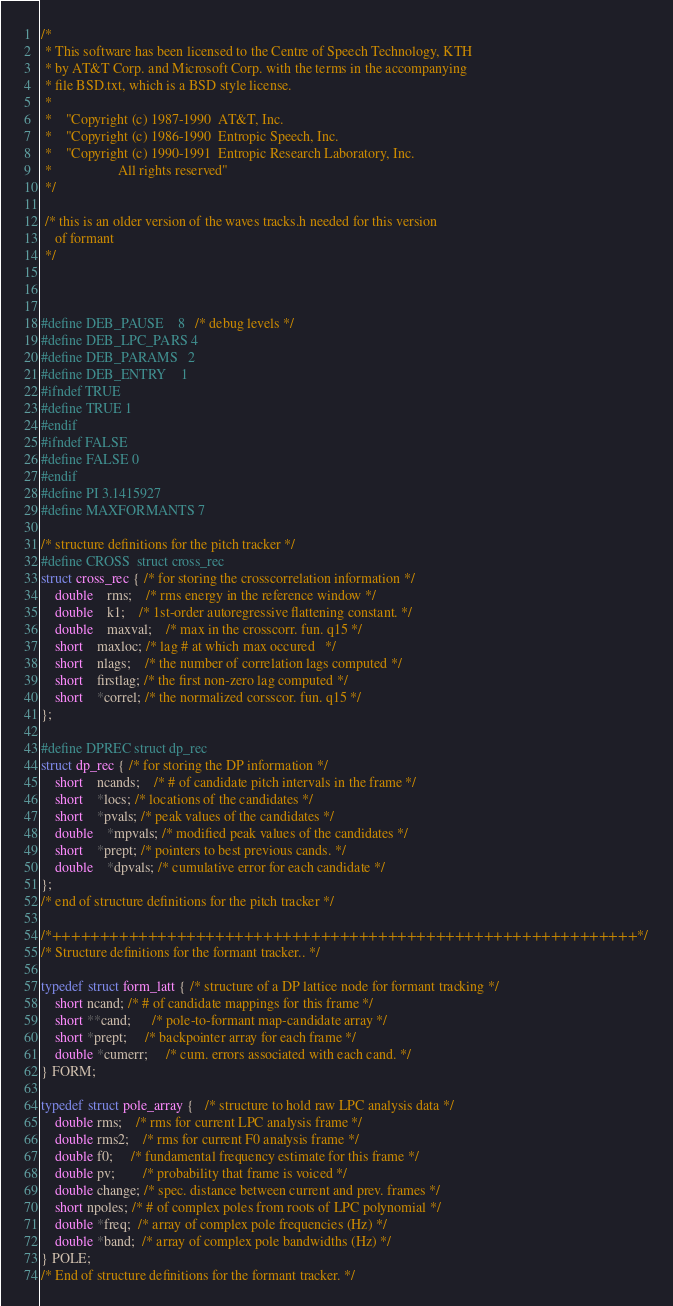<code> <loc_0><loc_0><loc_500><loc_500><_C_>/*
 * This software has been licensed to the Centre of Speech Technology, KTH
 * by AT&T Corp. and Microsoft Corp. with the terms in the accompanying
 * file BSD.txt, which is a BSD style license.
 *
 *    "Copyright (c) 1987-1990  AT&T, Inc.
 *    "Copyright (c) 1986-1990  Entropic Speech, Inc. 
 *    "Copyright (c) 1990-1991  Entropic Research Laboratory, Inc. 
 *                   All rights reserved"
 */

 /* this is an older version of the waves tracks.h needed for this version 
    of formant
 */



#define DEB_PAUSE	8	/* debug levels */
#define DEB_LPC_PARS	4
#define DEB_PARAMS	2
#define DEB_ENTRY	1
#ifndef TRUE
#define TRUE 1
#endif
#ifndef FALSE
#define FALSE 0
#endif
#define PI 3.1415927
#define MAXFORMANTS 7

/* structure definitions for the pitch tracker */
#define CROSS  struct cross_rec
struct cross_rec { /* for storing the crosscorrelation information */
	double	rms;	/* rms energy in the reference window */
	double	k1;	/* 1st-order autoregressive flattening constant. */
	double	maxval;	/* max in the crosscorr. fun. q15 */
	short	maxloc; /* lag # at which max occured	*/
	short	nlags;	/* the number of correlation lags computed */
	short	firstlag; /* the first non-zero lag computed */
	short	*correl; /* the normalized corsscor. fun. q15 */
};

#define DPREC struct dp_rec
struct dp_rec { /* for storing the DP information */
	short	ncands;	/* # of candidate pitch intervals in the frame */
	short	*locs; /* locations of the candidates */
	short	*pvals; /* peak values of the candidates */
	double	*mpvals; /* modified peak values of the candidates */
	short	*prept; /* pointers to best previous cands. */
	double	*dpvals; /* cumulative error for each candidate */
};
/* end of structure definitions for the pitch tracker */

/*+++++++++++++++++++++++++++++++++++++++++++++++++++++++++++++*/
/* Structure definitions for the formant tracker.. */

typedef struct form_latt { /* structure of a DP lattice node for formant tracking */
	short ncand; /* # of candidate mappings for this frame */
	short **cand;      /* pole-to-formant map-candidate array */
	short *prept;	 /* backpointer array for each frame */
	double *cumerr; 	 /* cum. errors associated with each cand. */
} FORM;

typedef struct pole_array {   /* structure to hold raw LPC analysis data */
	double rms;    /* rms for current LPC analysis frame */
	double rms2;    /* rms for current F0 analysis frame */
	double f0;     /* fundamental frequency estimate for this frame */
	double pv;		/* probability that frame is voiced */
	double change; /* spec. distance between current and prev. frames */
	short npoles; /* # of complex poles from roots of LPC polynomial */
	double *freq;  /* array of complex pole frequencies (Hz) */
	double *band;  /* array of complex pole bandwidths (Hz) */
} POLE;
/* End of structure definitions for the formant tracker. */
</code> 